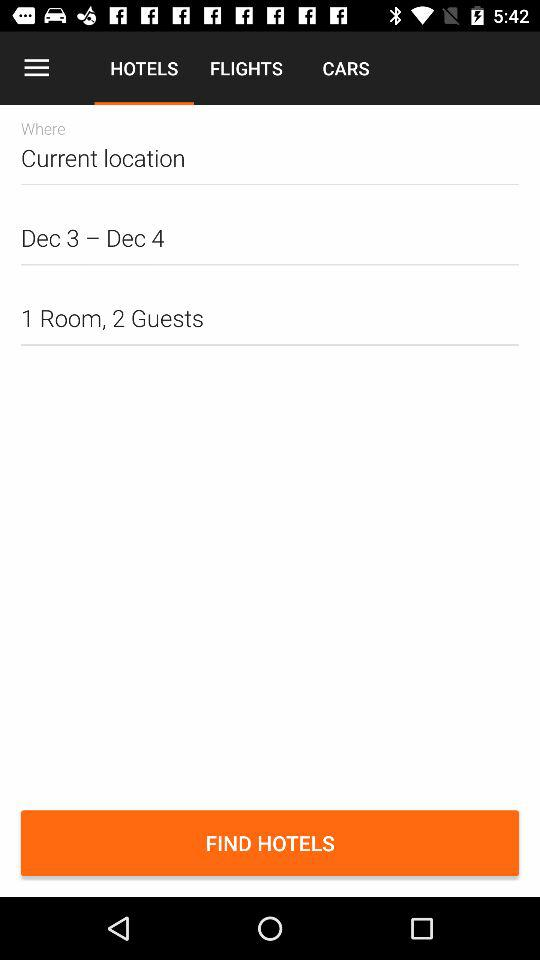How many days are selected?
Answer the question using a single word or phrase. 2 